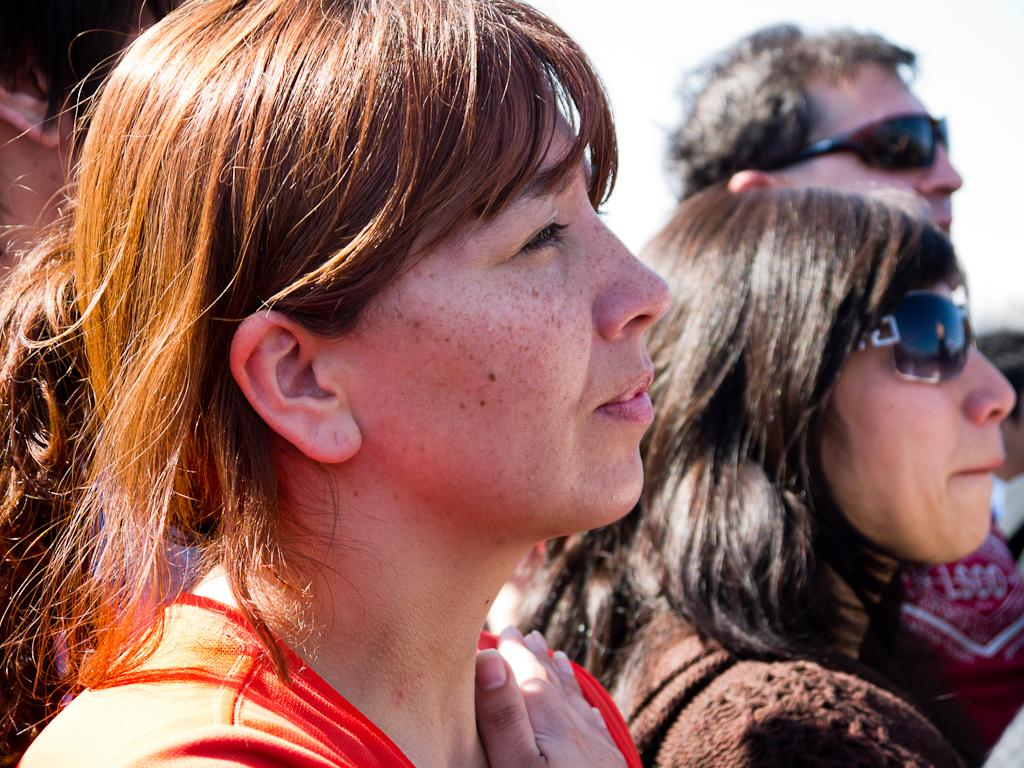How many people are present in the image? The number of people cannot be determined from the given fact, as it only states that there are persons in the image. What are the persons in the image doing? The actions of the persons cannot be determined from the given fact, as it only states that there are persons in the image. What type of crow can be seen sitting on the stem in the image? There is no crow or stem present in the image, as the given fact only states that there are persons in the image. 